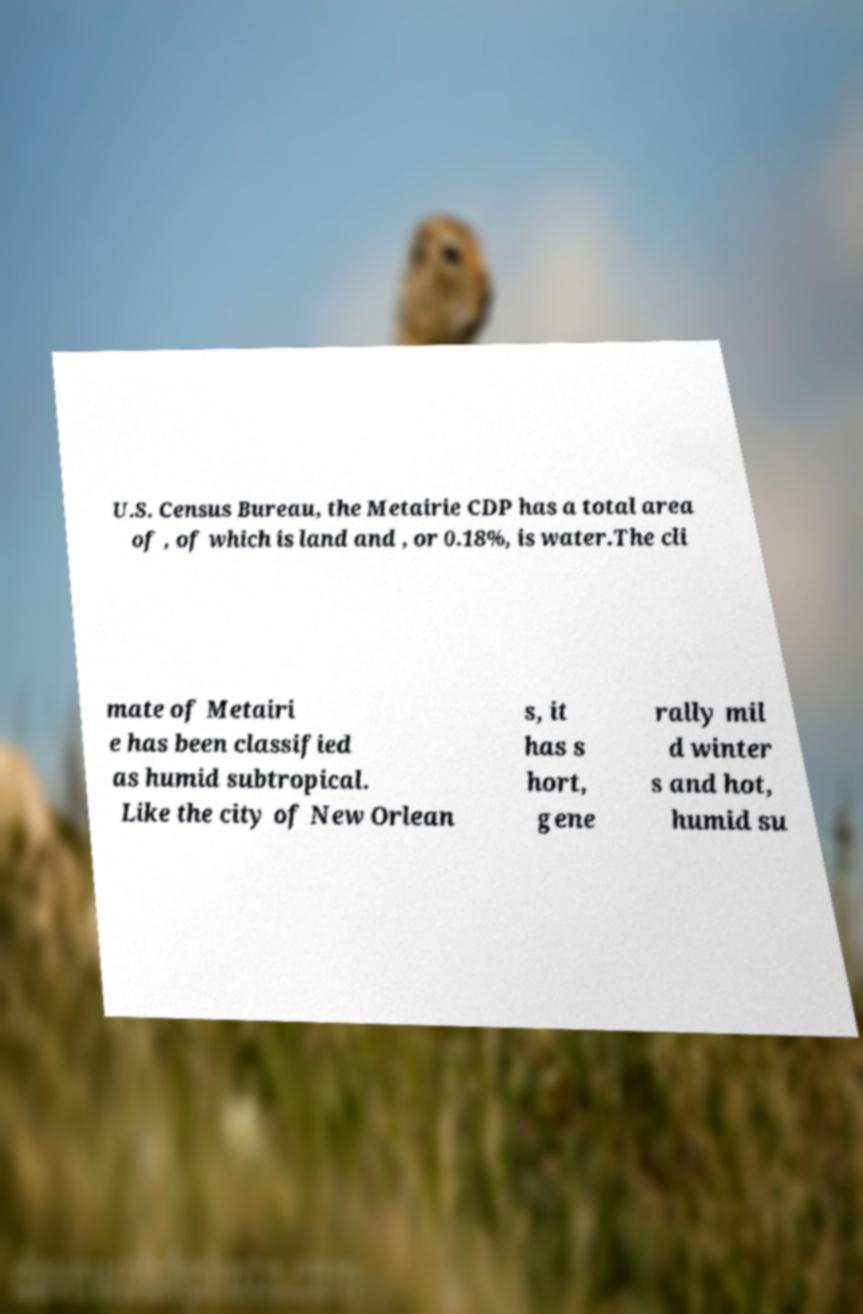Can you read and provide the text displayed in the image?This photo seems to have some interesting text. Can you extract and type it out for me? U.S. Census Bureau, the Metairie CDP has a total area of , of which is land and , or 0.18%, is water.The cli mate of Metairi e has been classified as humid subtropical. Like the city of New Orlean s, it has s hort, gene rally mil d winter s and hot, humid su 